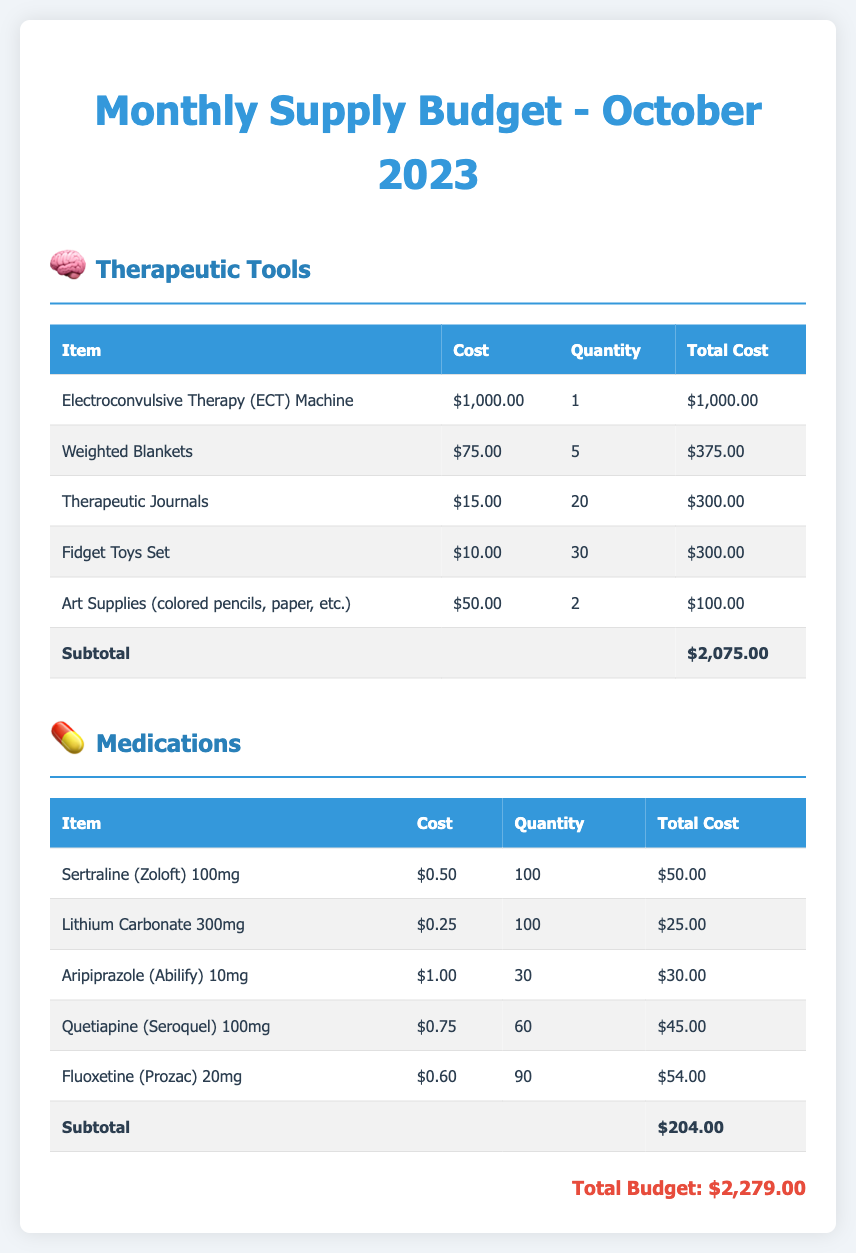what is the total budget? The total budget is found at the bottom of the document, which includes the subtotal of therapeutic tools and medications.
Answer: $2,279.00 how many therapeutic tools are listed? The document lists the therapeutic tools section with five items detailed in the table.
Answer: 5 what is the cost of the Electroconvulsive Therapy (ECT) Machine? The cost for the Electroconvulsive Therapy (ECT) Machine is provided in the table under therapeutic tools.
Answer: $1,000.00 what is the subtotal for medications? The subtotal for medications is found at the end of the medications table in the document.
Answer: $204.00 how many Weighted Blankets are included in the budget? The document specifies the quantity of Weighted Blankets in the therapeutic tools table.
Answer: 5 which item has the highest individual cost? The highest individual cost can be determined by comparing all items in the therapeutic tools section.
Answer: Electroconvulsive Therapy (ECT) Machine what is the total cost of Fidget Toys Set? The total cost for the Fidget Toys Set can be calculated from the quantity and cost per item found in the therapeutic tools table.
Answer: $300.00 what is the cost of Fluoxetine (Prozac) 20mg? The cost for Fluoxetine (Prozac) 20mg is listed in the medications table within the document.
Answer: $0.60 how many Art Supplies are included in the budget? The quantity of Art Supplies is provided in the therapeutic tools section of the budget document.
Answer: 2 